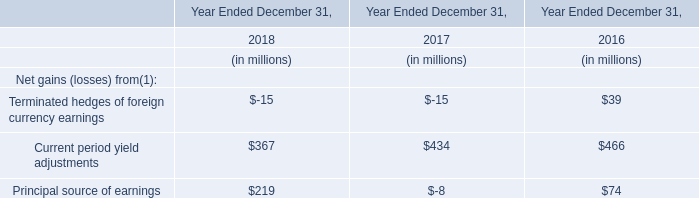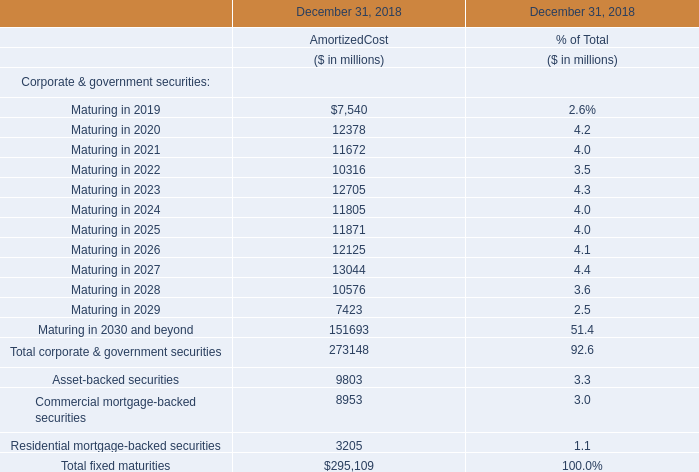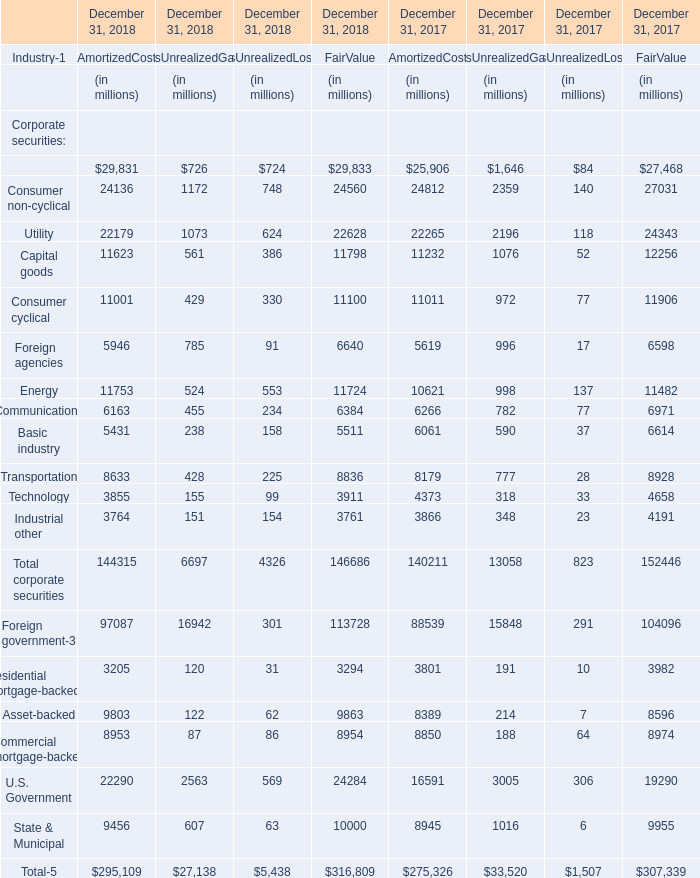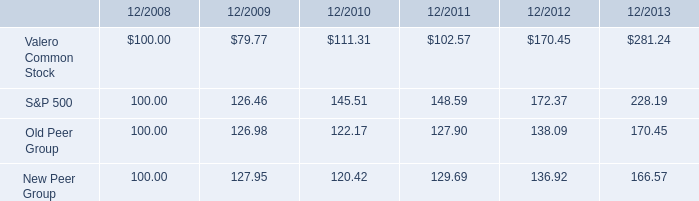What's the average of the Terminated hedges of foreign currency earnings for Net gains (losses) from(1) in the years where Utility for Corporate securities for AmortizedCos is positive? (in million) 
Computations: ((-15 - 15) / 2)
Answer: -15.0. 